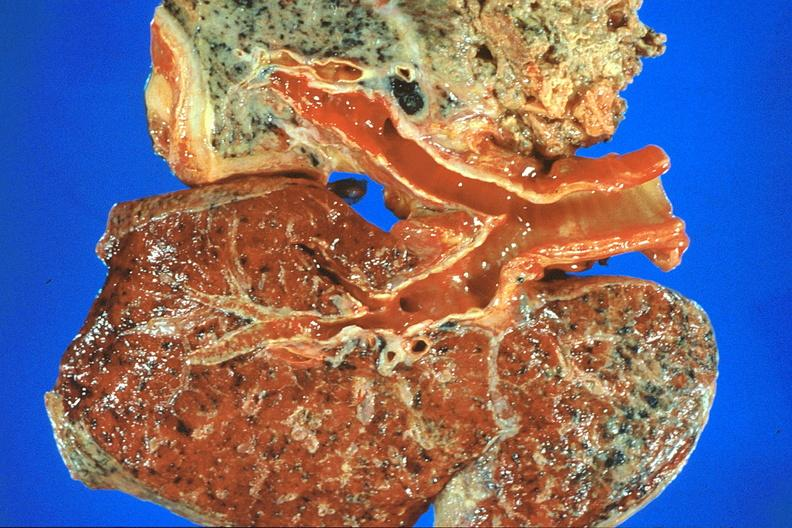s respiratory present?
Answer the question using a single word or phrase. Yes 